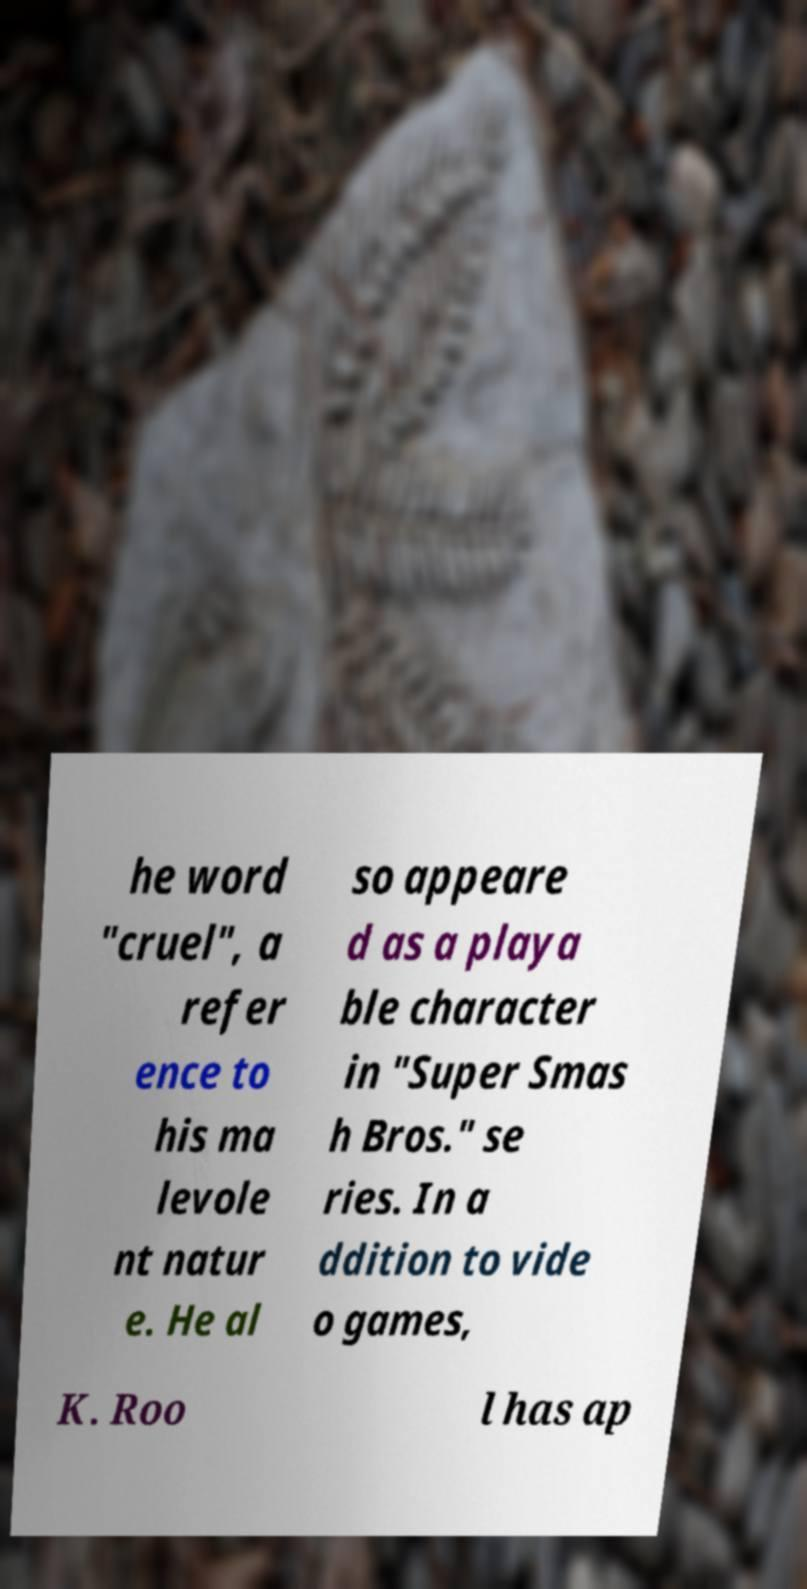I need the written content from this picture converted into text. Can you do that? he word "cruel", a refer ence to his ma levole nt natur e. He al so appeare d as a playa ble character in "Super Smas h Bros." se ries. In a ddition to vide o games, K. Roo l has ap 